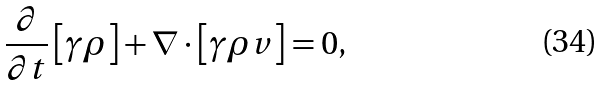<formula> <loc_0><loc_0><loc_500><loc_500>\frac { \partial } { \partial t } \left [ \gamma \rho \right ] + \nabla \cdot \left [ \gamma \rho v \right ] = 0 ,</formula> 